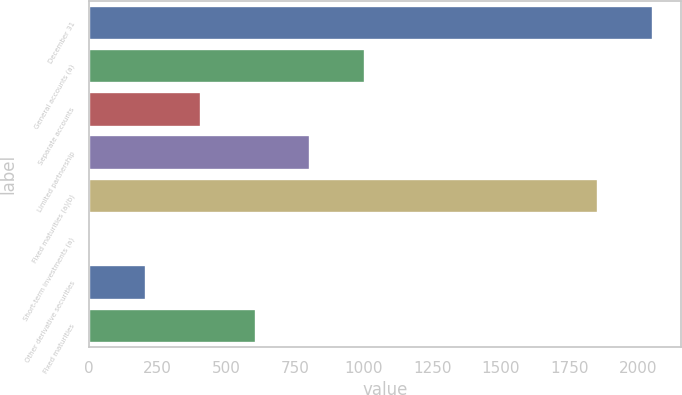<chart> <loc_0><loc_0><loc_500><loc_500><bar_chart><fcel>December 31<fcel>General accounts (a)<fcel>Separate accounts<fcel>Limited partnership<fcel>Fixed maturities (a)(b)<fcel>Short-term investments (a)<fcel>Other derivative securities<fcel>Fixed maturities<nl><fcel>2054.7<fcel>1005.5<fcel>406.4<fcel>805.8<fcel>1855<fcel>7<fcel>206.7<fcel>606.1<nl></chart> 